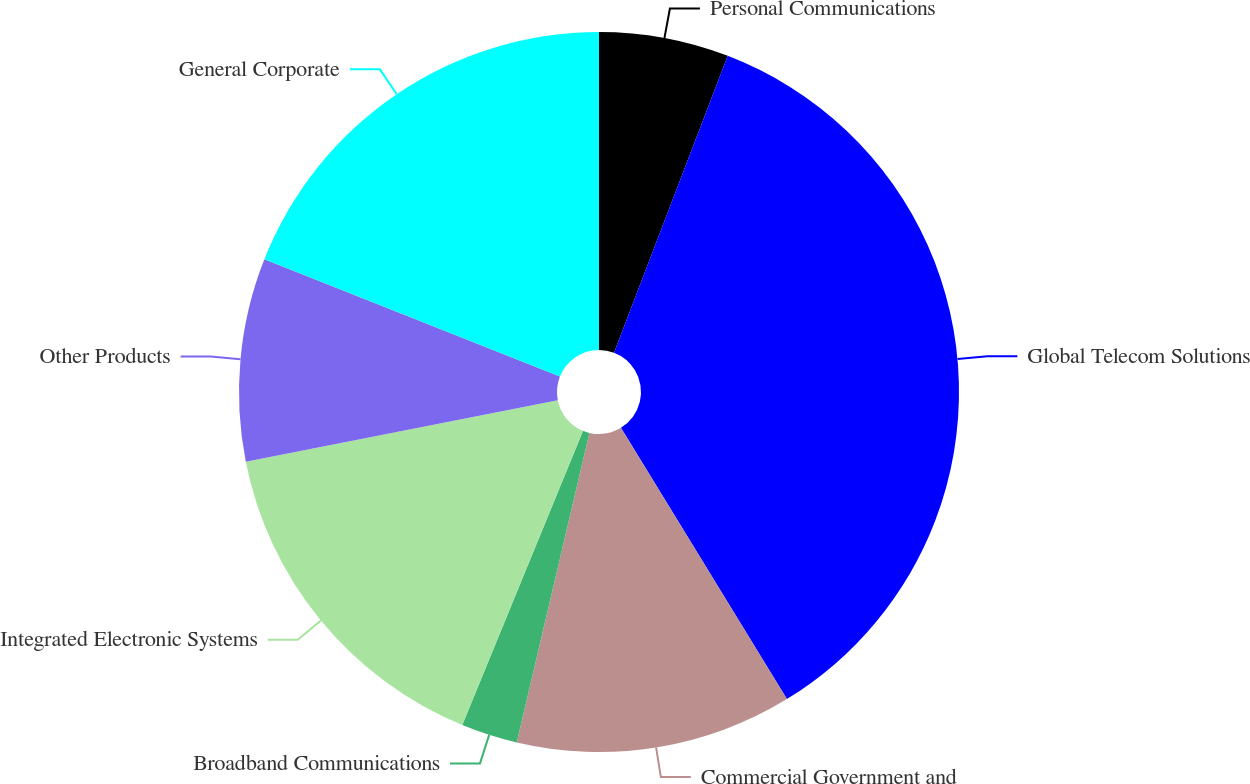<chart> <loc_0><loc_0><loc_500><loc_500><pie_chart><fcel>Personal Communications<fcel>Global Telecom Solutions<fcel>Commercial Government and<fcel>Broadband Communications<fcel>Integrated Electronic Systems<fcel>Other Products<fcel>General Corporate<nl><fcel>5.82%<fcel>35.44%<fcel>12.41%<fcel>2.53%<fcel>15.7%<fcel>9.11%<fcel>18.99%<nl></chart> 